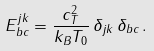Convert formula to latex. <formula><loc_0><loc_0><loc_500><loc_500>E ^ { j k } _ { b c } = \frac { c _ { T } ^ { 2 } } { k _ { B } T _ { 0 } } \, \delta _ { j k } \, \delta _ { b c } \, .</formula> 